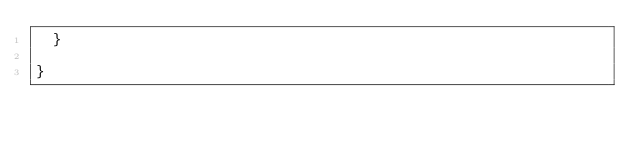Convert code to text. <code><loc_0><loc_0><loc_500><loc_500><_Java_>	}

}
</code> 